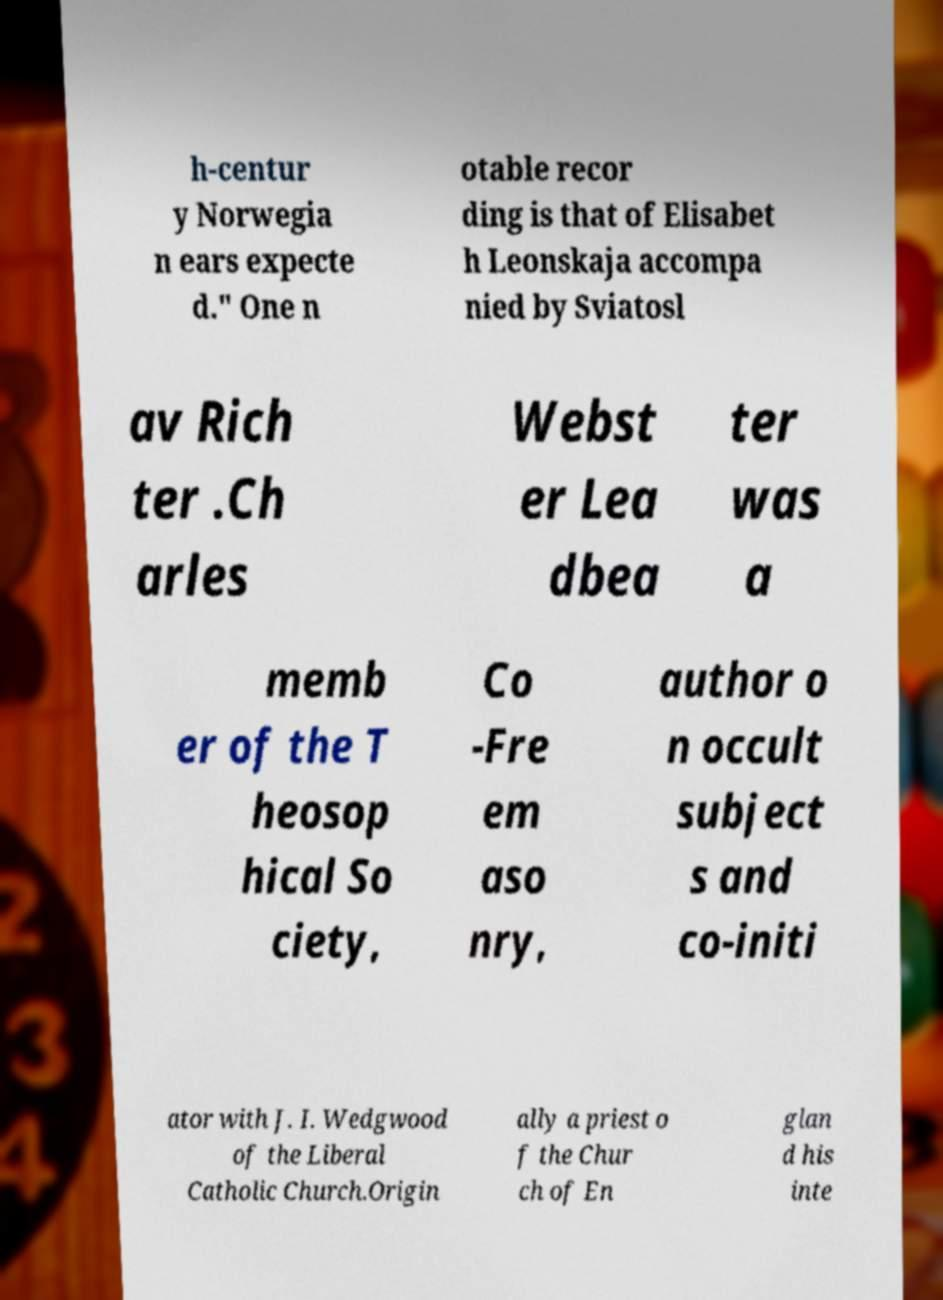Please read and relay the text visible in this image. What does it say? h-centur y Norwegia n ears expecte d." One n otable recor ding is that of Elisabet h Leonskaja accompa nied by Sviatosl av Rich ter .Ch arles Webst er Lea dbea ter was a memb er of the T heosop hical So ciety, Co -Fre em aso nry, author o n occult subject s and co-initi ator with J. I. Wedgwood of the Liberal Catholic Church.Origin ally a priest o f the Chur ch of En glan d his inte 